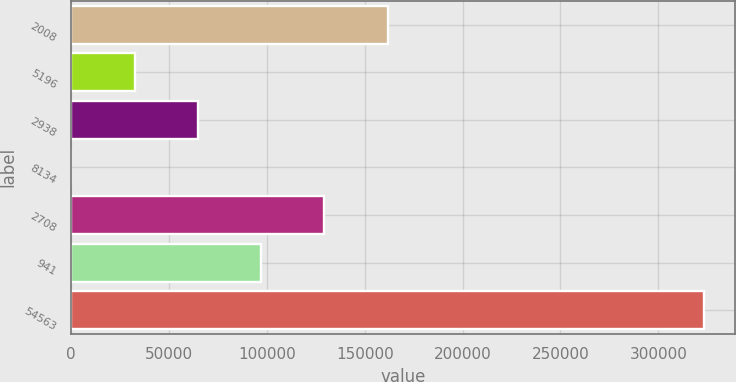Convert chart. <chart><loc_0><loc_0><loc_500><loc_500><bar_chart><fcel>2008<fcel>5196<fcel>2938<fcel>8134<fcel>2708<fcel>941<fcel>54563<nl><fcel>161648<fcel>32384.8<fcel>64700.6<fcel>69<fcel>129332<fcel>97016.4<fcel>323227<nl></chart> 